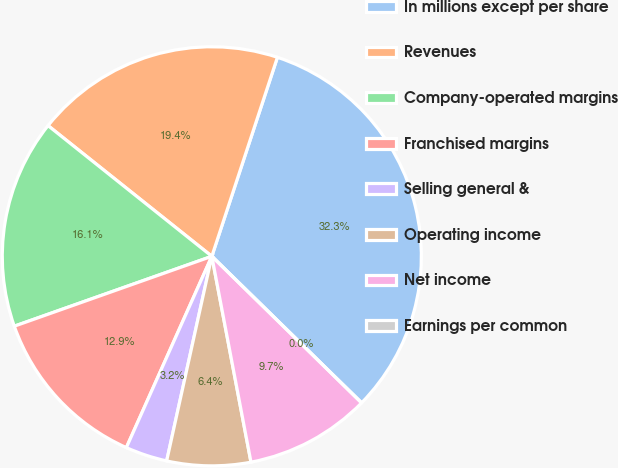Convert chart to OTSL. <chart><loc_0><loc_0><loc_500><loc_500><pie_chart><fcel>In millions except per share<fcel>Revenues<fcel>Company-operated margins<fcel>Franchised margins<fcel>Selling general &<fcel>Operating income<fcel>Net income<fcel>Earnings per common<nl><fcel>32.26%<fcel>19.35%<fcel>16.13%<fcel>12.9%<fcel>3.23%<fcel>6.45%<fcel>9.68%<fcel>0.0%<nl></chart> 